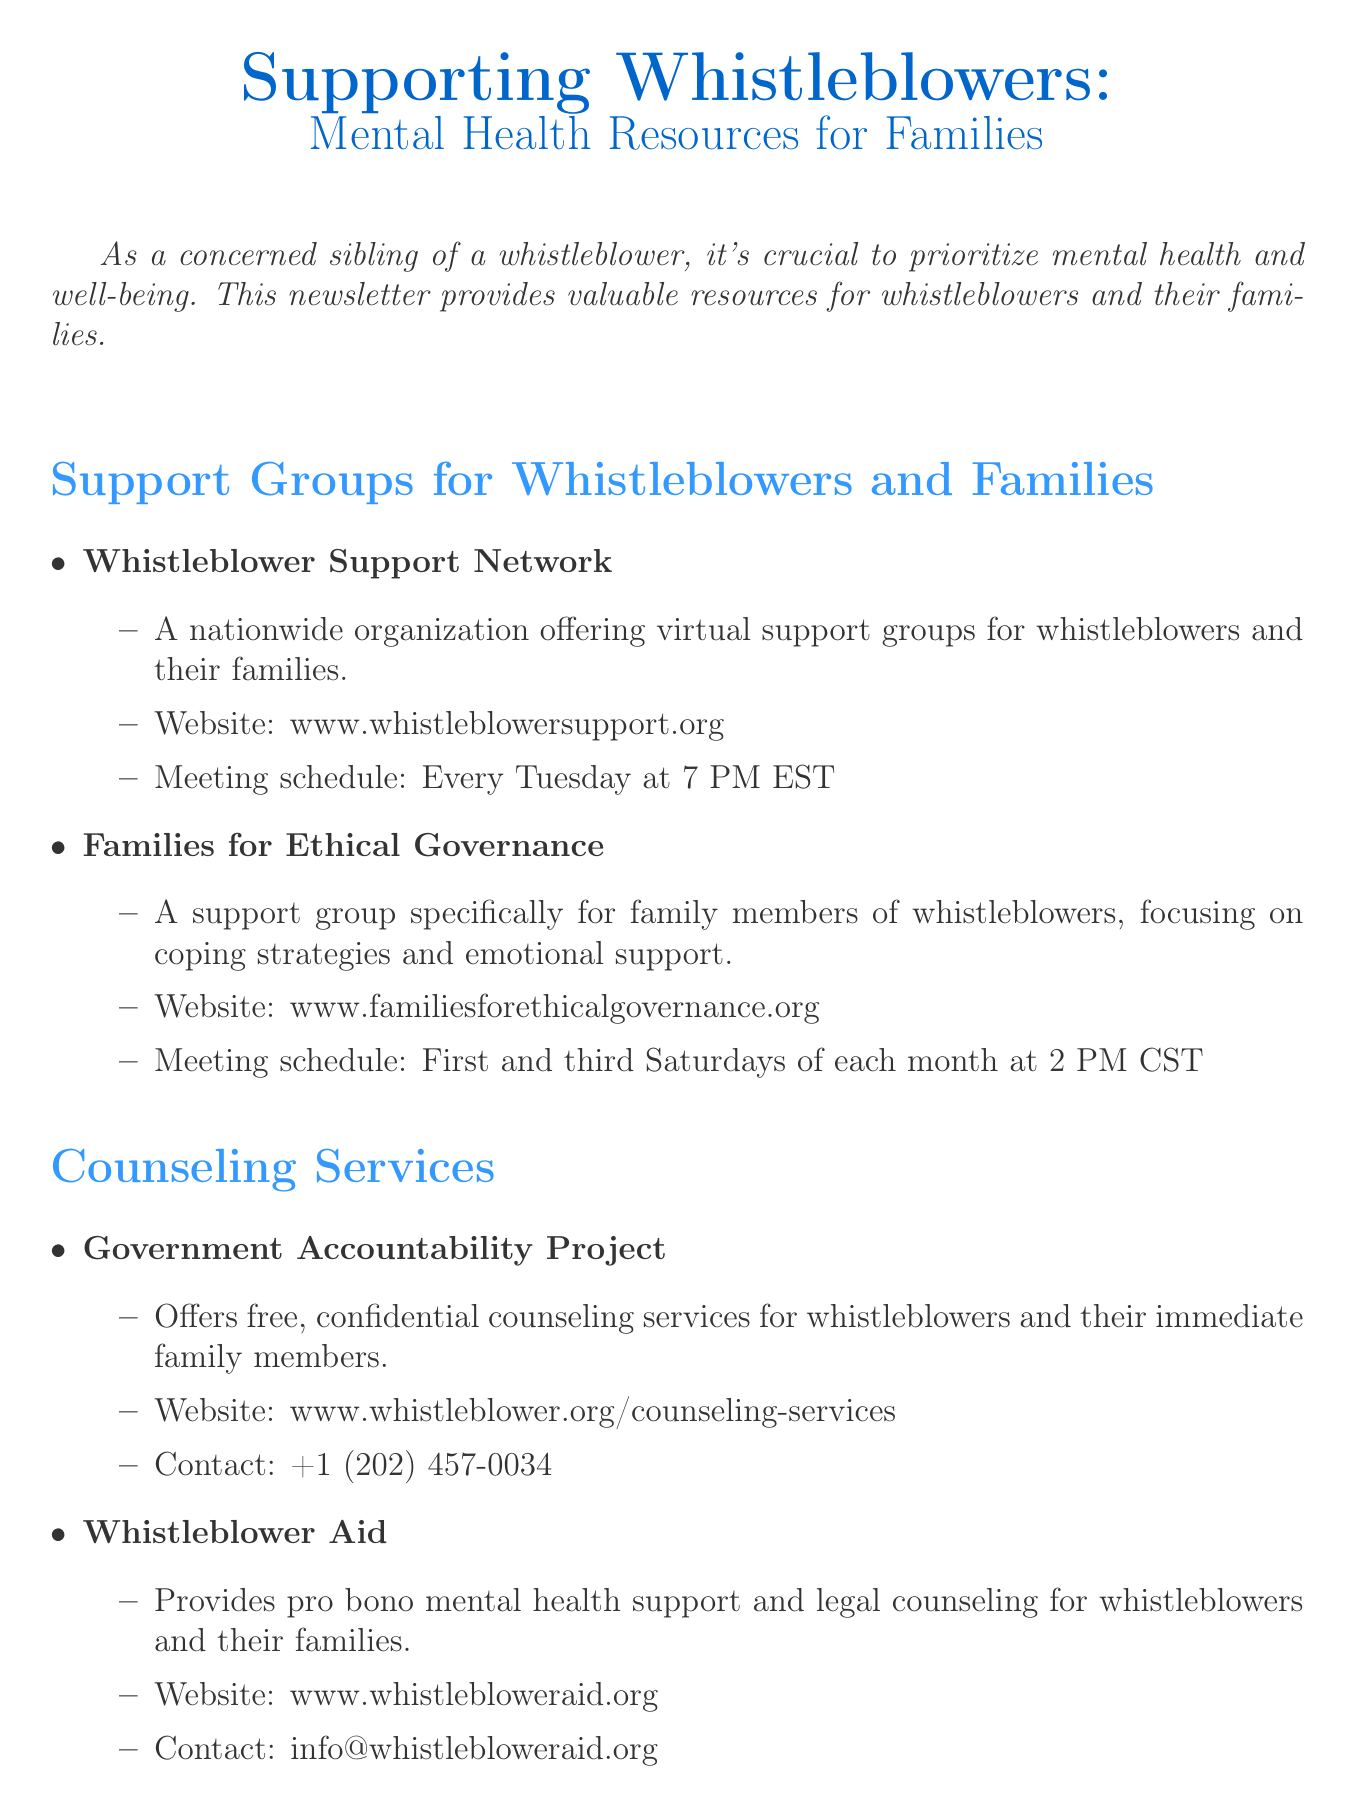What is the title of the newsletter? The title is clearly stated at the beginning of the document, indicating the focus on mental health resources for families of whistleblowers.
Answer: Supporting Whistleblowers: Mental Health Resources for Families When do the Whistleblower Support Network meetings occur? The meeting schedule for this support group is specified in the document, making it easy to see when they meet.
Answer: Every Tuesday at 7 PM EST What type of support does Whistleblower Aid provide? The document explicitly mentions the services offered, allowing one to quickly understand the focus of this organization.
Answer: Pro bono mental health support and legal counseling How often does Families for Ethical Governance meet? The meeting frequency for this specific support group is listed, which helps in understanding the availability of support.
Answer: First and third Saturdays of each month at 2 PM CST What should a sibling do to support their whistleblower sibling? The document includes a special feature with tips for siblings, providing valuable guidance on how to be supportive.
Answer: Listen without judgment How can the National Whistleblower Center help? The resources available from this center are detailed in the document, which outlines its relevance to mental health maintenance.
Answer: Comprehensive guide on maintaining mental health What is the contact number for the Government Accountability Project? The contact information for counseling services is outlined in the document, making it straightforward to find.
Answer: +1 (202) 457-0034 Why is staying informed about whistleblower rights important? The document emphasizes the significance of being informed in the context of sibling support, highlighting its crucial role.
Answer: Support is invaluable 